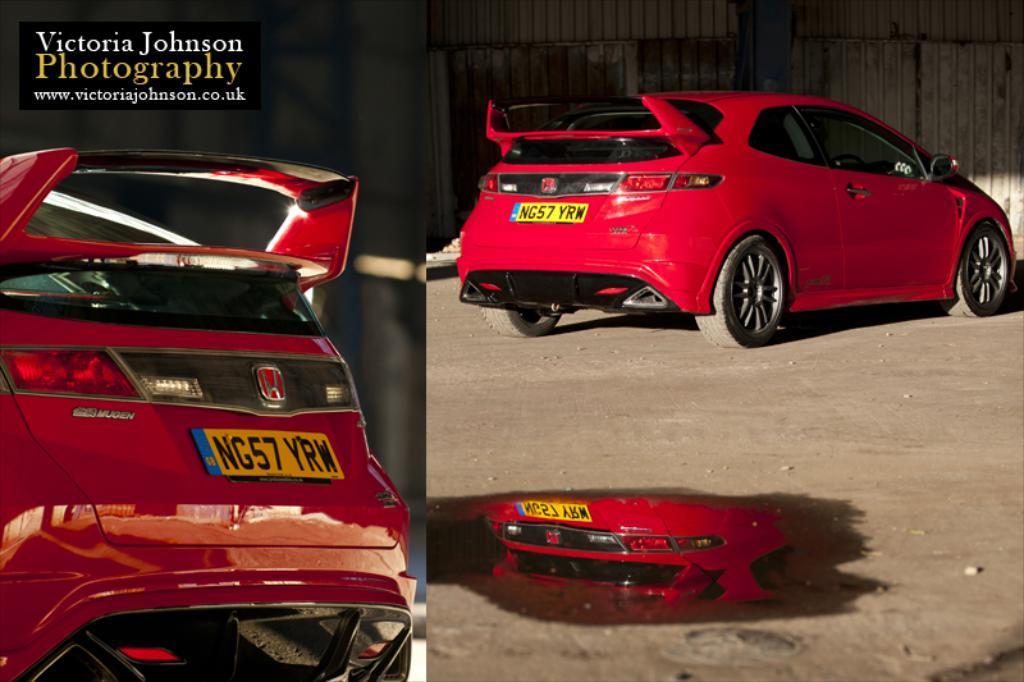Can you describe this image briefly? This picture is a collage of two images. In these two images we can observe red color car on the road. We can observe a watermark on the left side. On the right side there is some water in which we can observe reflection of this red color car. In the background there is a wall. 